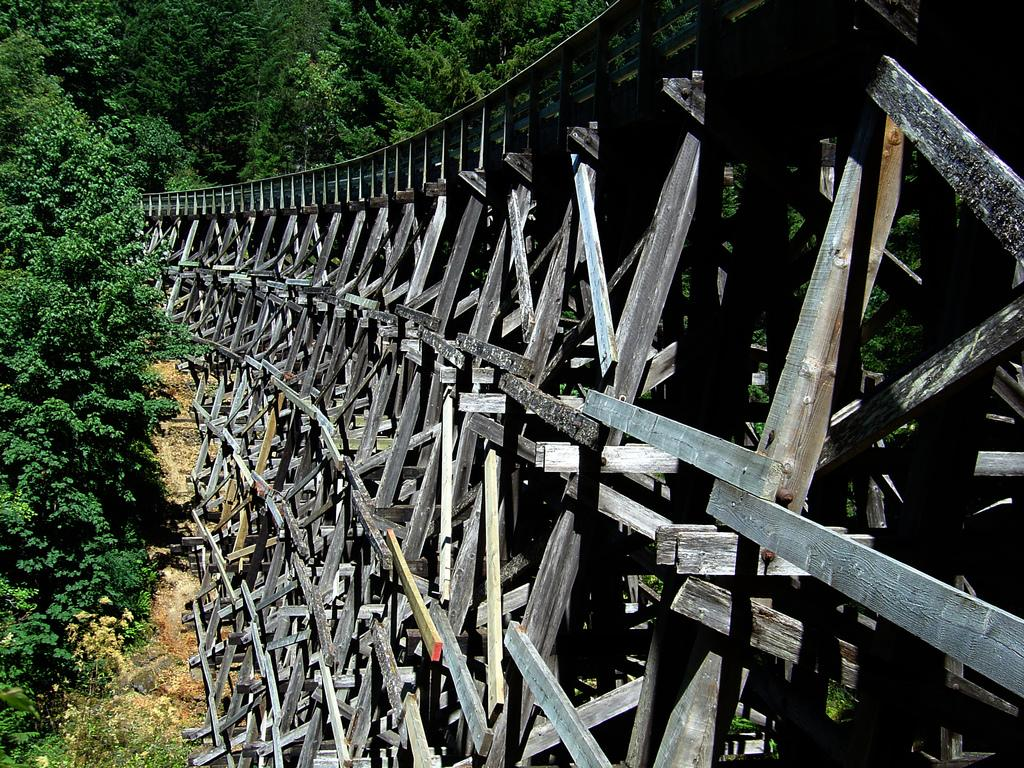What is the main structure in the center of the image? There is a bridge in the center of the image. What type of vegetation can be seen on the left side and in the background of the image? There are trees on the left side and in the background of the image. What is present at the bottom of the image? There is sand and rocks at the bottom of the image. Can you describe the texture of the tiger's fur in the image? There is no tiger present in the image, so we cannot describe its fur texture. 